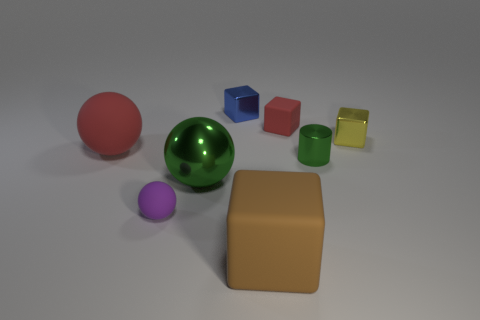Is the number of blue shiny objects that are behind the green sphere greater than the number of tiny yellow metal blocks in front of the large cube? Upon closely examining the image, I can confirm that there are no blue shiny objects visible behind the green sphere. On the other hand, there is one tiny yellow metal block placed in front of the large cube. Therefore, since there are no blue objects to compare with the single yellow block, the number of blue shiny objects behind the green sphere is not greater than the number of tiny yellow metal blocks in front of the large cube. 